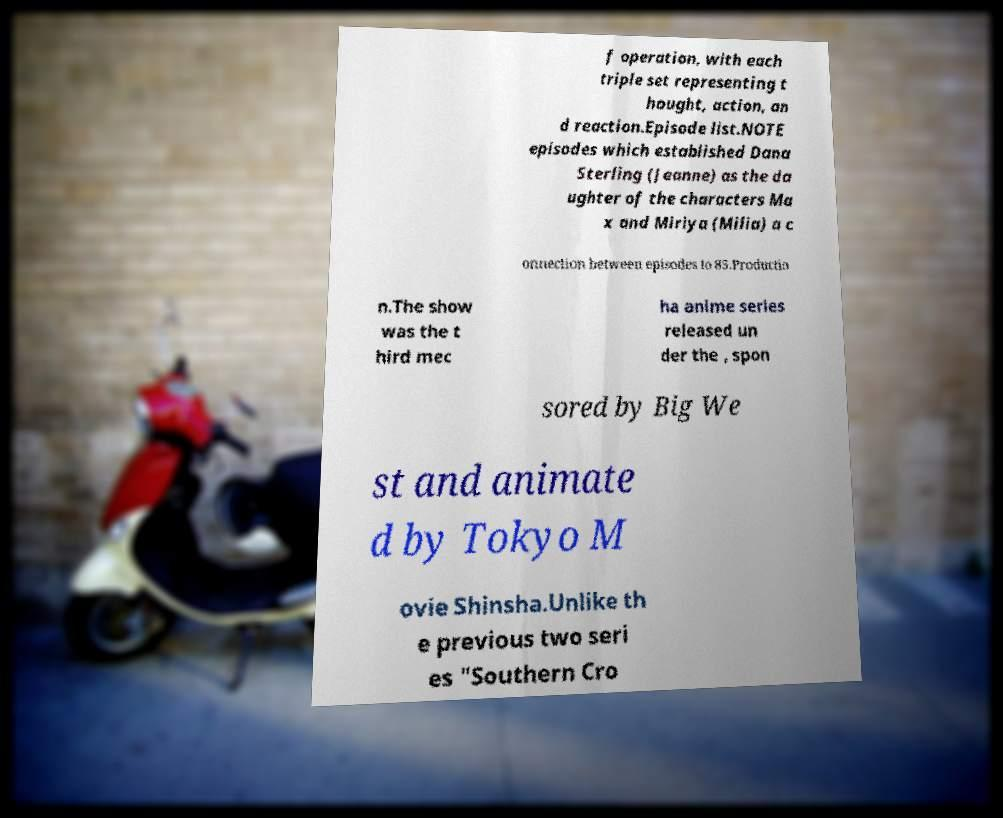Can you read and provide the text displayed in the image?This photo seems to have some interesting text. Can you extract and type it out for me? f operation, with each triple set representing t hought, action, an d reaction.Episode list.NOTE episodes which established Dana Sterling (Jeanne) as the da ughter of the characters Ma x and Miriya (Milia) a c onnection between episodes to 85.Productio n.The show was the t hird mec ha anime series released un der the , spon sored by Big We st and animate d by Tokyo M ovie Shinsha.Unlike th e previous two seri es "Southern Cro 